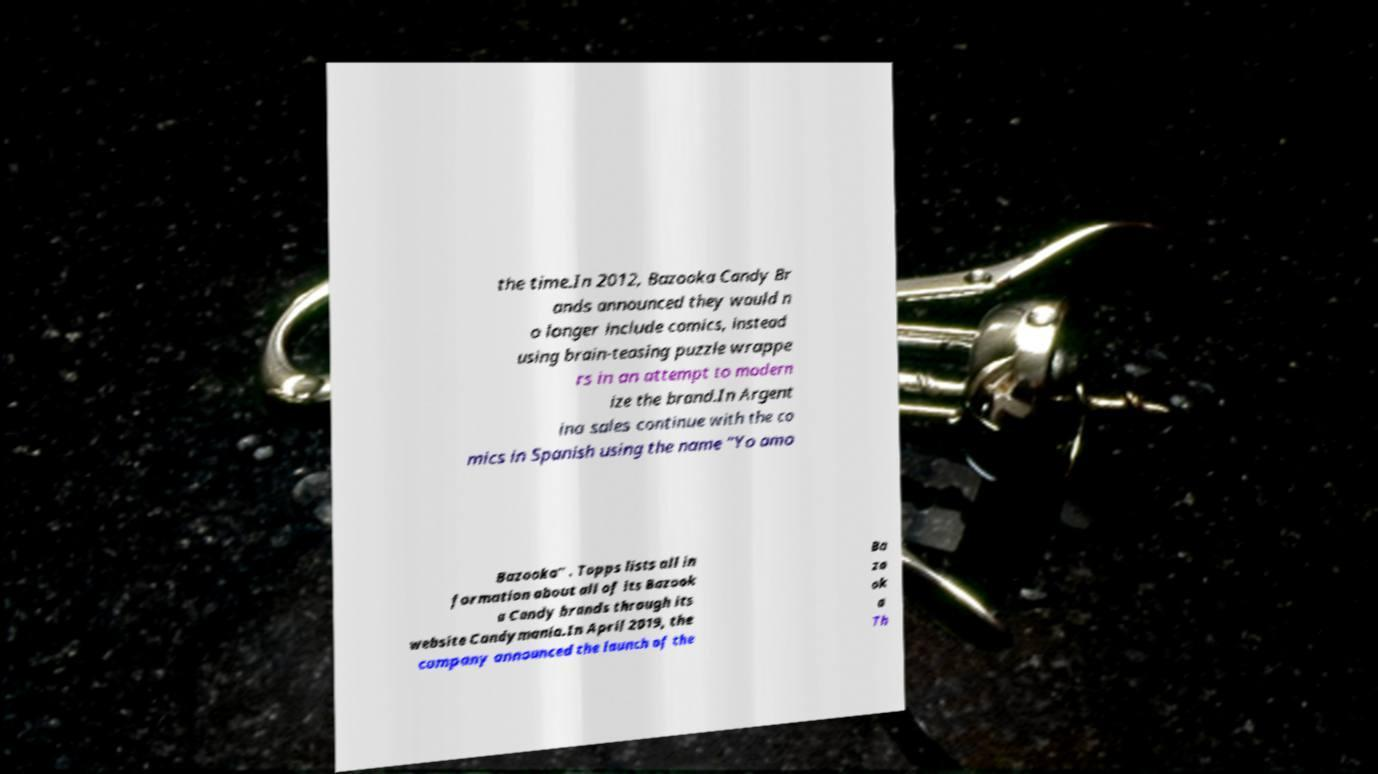Please read and relay the text visible in this image. What does it say? the time.In 2012, Bazooka Candy Br ands announced they would n o longer include comics, instead using brain-teasing puzzle wrappe rs in an attempt to modern ize the brand.In Argent ina sales continue with the co mics in Spanish using the name "Yo amo Bazooka" . Topps lists all in formation about all of its Bazook a Candy brands through its website Candymania.In April 2019, the company announced the launch of the Ba zo ok a Th 